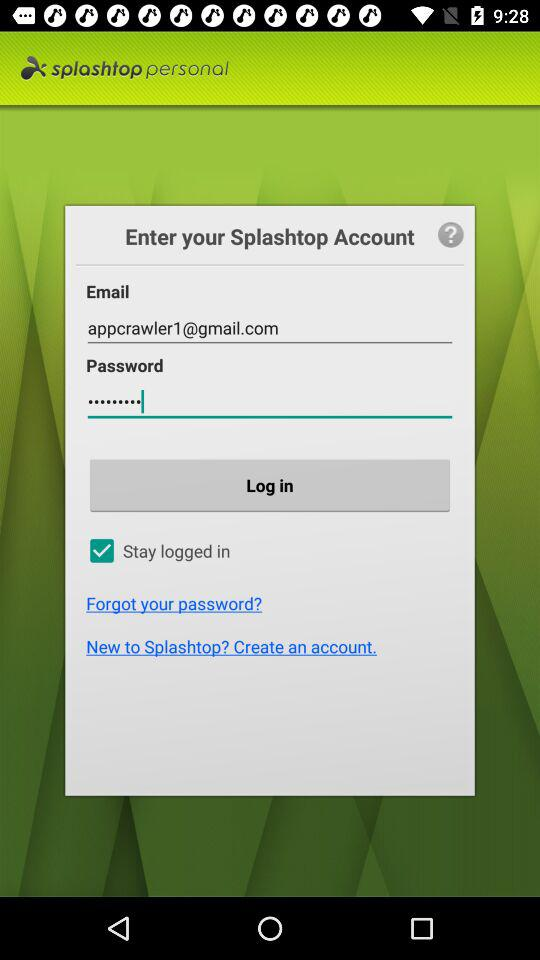How many fields are there on this screen that require a user to type in information?
Answer the question using a single word or phrase. 2 